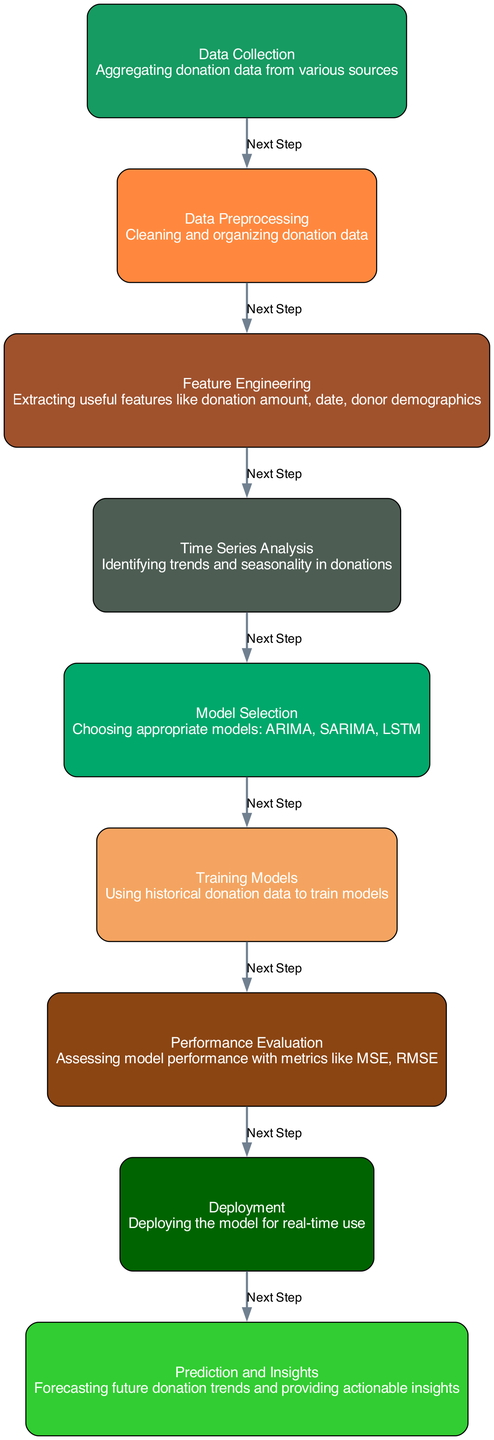What is the first step in the diagram? The first step is "Data Collection," which indicates that the initial phase involves aggregating donation data from various sources before moving on to the next steps.
Answer: Data Collection How many nodes are present in the diagram? Counting the nodes listed, there are a total of nine nodes represented in the diagram.
Answer: 9 What is the last step in the analysis process? The last step is "Prediction and Insights," indicating that the final outcome involves forecasting future donation trends and providing actionable insights after deployment.
Answer: Prediction and Insights What is the relationship between "Data Preprocessing" and "Feature Engineering"? The diagram shows a direct connection labeled "Next Step" from "Data Preprocessing" (node 2) to "Feature Engineering" (node 3), indicating that after preprocessing, the next step is to extract useful features.
Answer: Next Step Which model selection is considered as part of the "Model Selection" node? The models mentioned in the "Model Selection" node include ARIMA, SARIMA, and LSTM, all of which are appropriate for the analysis of seasonal trends in donations.
Answer: ARIMA, SARIMA, LSTM Describe the overall flow of the machine learning process shown in the diagram. The flow begins with Data Collection, progresses through steps of Preprocessing, Feature Engineering, and Time Series Analysis, follows through Model Selection and Training, then moves to Performance Evaluation, Deployment, and finally culminates in Prediction and Insights, creating an end-to-end machine learning analysis pipeline for donations.
Answer: End-to-end pipeline How does the "Performance Evaluation" relate to "Training Models"? The diagram emphasizes that "Performance Evaluation" (node 7) directly follows "Training Models" (node 6), indicating that assessing performance occurs after training the models with historical data.
Answer: Next Step What metrics are implied to be used in the "Performance Evaluation"? The "Performance Evaluation" node mentions metrics such as MSE and RMSE, which are commonly used to evaluate the performance of the models trained on donation data.
Answer: MSE, RMSE What is the significance of the "Deployment" step? The "Deployment" step refers to making the trained model available for real-time use, indicating that an operational version of the model is necessary for forecasting and generating insights from ongoing donation data.
Answer: Real-time use 